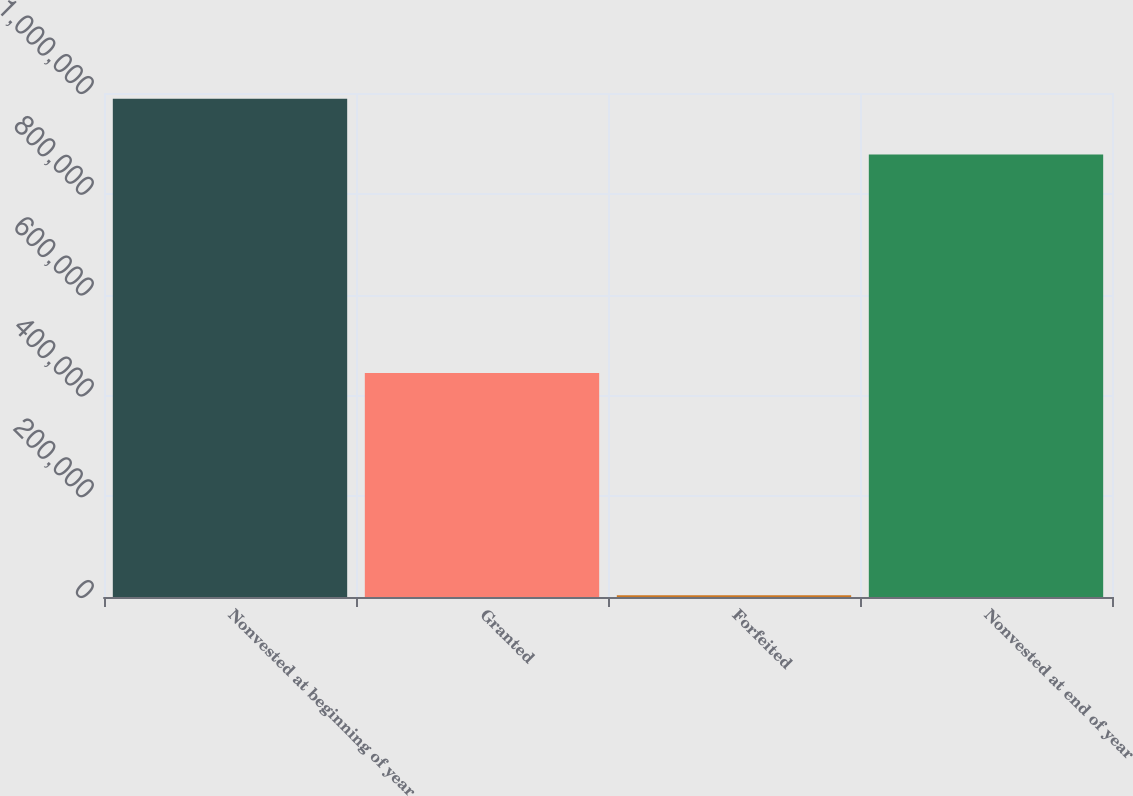Convert chart. <chart><loc_0><loc_0><loc_500><loc_500><bar_chart><fcel>Nonvested at beginning of year<fcel>Granted<fcel>Forfeited<fcel>Nonvested at end of year<nl><fcel>988637<fcel>444543<fcel>3388<fcel>878104<nl></chart> 